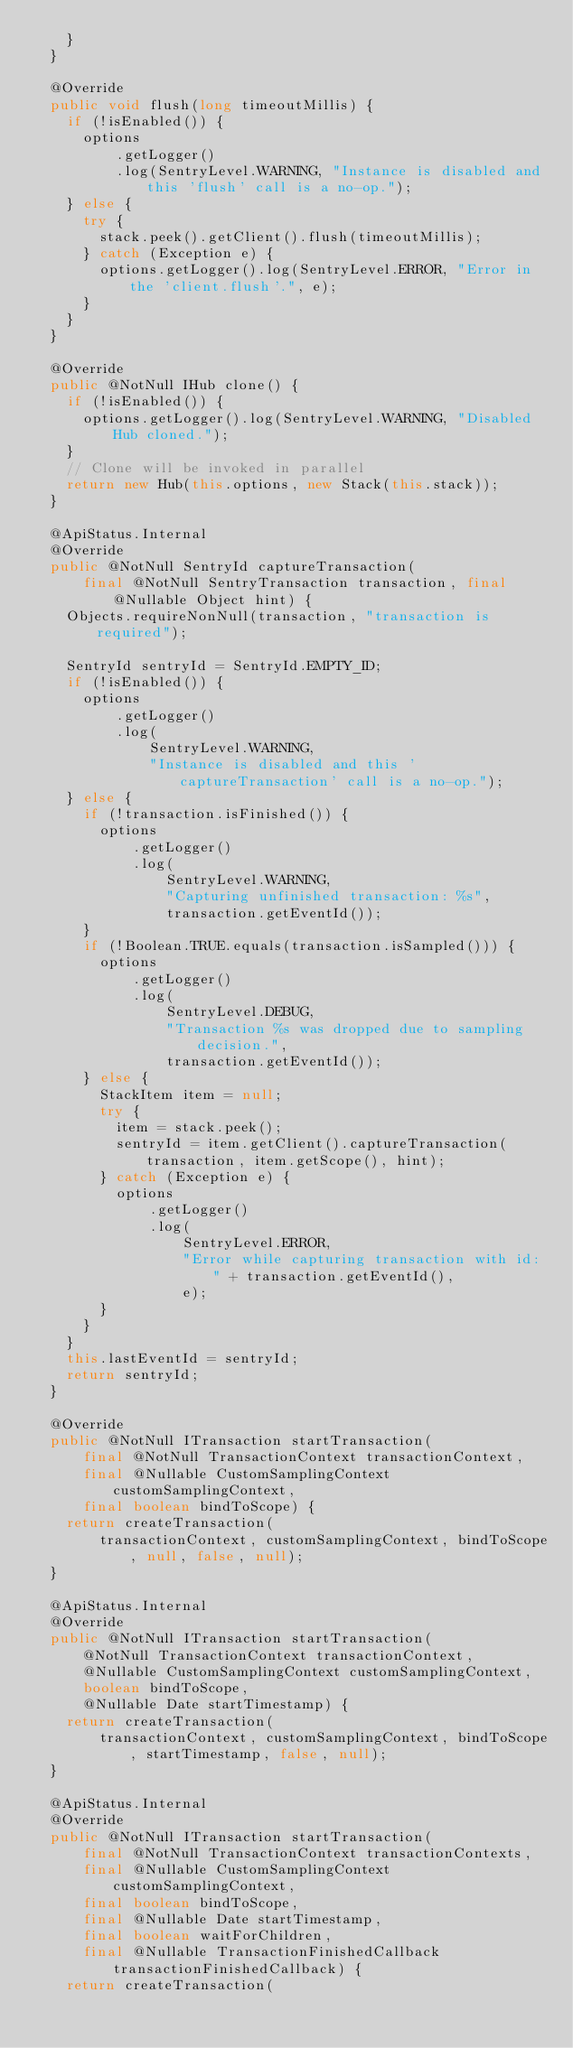<code> <loc_0><loc_0><loc_500><loc_500><_Java_>    }
  }

  @Override
  public void flush(long timeoutMillis) {
    if (!isEnabled()) {
      options
          .getLogger()
          .log(SentryLevel.WARNING, "Instance is disabled and this 'flush' call is a no-op.");
    } else {
      try {
        stack.peek().getClient().flush(timeoutMillis);
      } catch (Exception e) {
        options.getLogger().log(SentryLevel.ERROR, "Error in the 'client.flush'.", e);
      }
    }
  }

  @Override
  public @NotNull IHub clone() {
    if (!isEnabled()) {
      options.getLogger().log(SentryLevel.WARNING, "Disabled Hub cloned.");
    }
    // Clone will be invoked in parallel
    return new Hub(this.options, new Stack(this.stack));
  }

  @ApiStatus.Internal
  @Override
  public @NotNull SentryId captureTransaction(
      final @NotNull SentryTransaction transaction, final @Nullable Object hint) {
    Objects.requireNonNull(transaction, "transaction is required");

    SentryId sentryId = SentryId.EMPTY_ID;
    if (!isEnabled()) {
      options
          .getLogger()
          .log(
              SentryLevel.WARNING,
              "Instance is disabled and this 'captureTransaction' call is a no-op.");
    } else {
      if (!transaction.isFinished()) {
        options
            .getLogger()
            .log(
                SentryLevel.WARNING,
                "Capturing unfinished transaction: %s",
                transaction.getEventId());
      }
      if (!Boolean.TRUE.equals(transaction.isSampled())) {
        options
            .getLogger()
            .log(
                SentryLevel.DEBUG,
                "Transaction %s was dropped due to sampling decision.",
                transaction.getEventId());
      } else {
        StackItem item = null;
        try {
          item = stack.peek();
          sentryId = item.getClient().captureTransaction(transaction, item.getScope(), hint);
        } catch (Exception e) {
          options
              .getLogger()
              .log(
                  SentryLevel.ERROR,
                  "Error while capturing transaction with id: " + transaction.getEventId(),
                  e);
        }
      }
    }
    this.lastEventId = sentryId;
    return sentryId;
  }

  @Override
  public @NotNull ITransaction startTransaction(
      final @NotNull TransactionContext transactionContext,
      final @Nullable CustomSamplingContext customSamplingContext,
      final boolean bindToScope) {
    return createTransaction(
        transactionContext, customSamplingContext, bindToScope, null, false, null);
  }

  @ApiStatus.Internal
  @Override
  public @NotNull ITransaction startTransaction(
      @NotNull TransactionContext transactionContext,
      @Nullable CustomSamplingContext customSamplingContext,
      boolean bindToScope,
      @Nullable Date startTimestamp) {
    return createTransaction(
        transactionContext, customSamplingContext, bindToScope, startTimestamp, false, null);
  }

  @ApiStatus.Internal
  @Override
  public @NotNull ITransaction startTransaction(
      final @NotNull TransactionContext transactionContexts,
      final @Nullable CustomSamplingContext customSamplingContext,
      final boolean bindToScope,
      final @Nullable Date startTimestamp,
      final boolean waitForChildren,
      final @Nullable TransactionFinishedCallback transactionFinishedCallback) {
    return createTransaction(</code> 